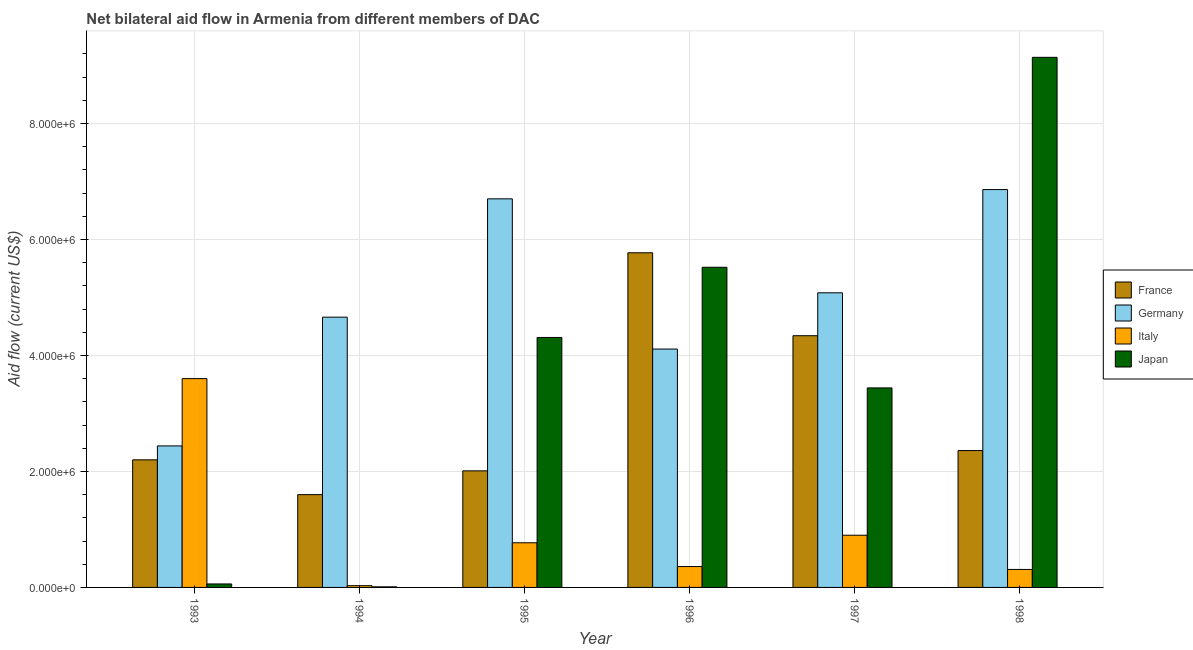How many bars are there on the 1st tick from the left?
Give a very brief answer. 4. What is the amount of aid given by italy in 1997?
Your answer should be compact. 9.00e+05. Across all years, what is the maximum amount of aid given by japan?
Your answer should be compact. 9.14e+06. Across all years, what is the minimum amount of aid given by italy?
Your response must be concise. 3.00e+04. In which year was the amount of aid given by japan maximum?
Provide a succinct answer. 1998. What is the total amount of aid given by france in the graph?
Make the answer very short. 1.83e+07. What is the difference between the amount of aid given by germany in 1994 and that in 1995?
Offer a very short reply. -2.04e+06. What is the difference between the amount of aid given by italy in 1995 and the amount of aid given by france in 1997?
Your answer should be very brief. -1.30e+05. What is the average amount of aid given by italy per year?
Offer a terse response. 9.95e+05. In how many years, is the amount of aid given by japan greater than 1600000 US$?
Make the answer very short. 4. What is the ratio of the amount of aid given by japan in 1993 to that in 1998?
Offer a terse response. 0.01. Is the amount of aid given by italy in 1993 less than that in 1996?
Ensure brevity in your answer.  No. What is the difference between the highest and the second highest amount of aid given by germany?
Make the answer very short. 1.60e+05. What is the difference between the highest and the lowest amount of aid given by germany?
Your response must be concise. 4.42e+06. In how many years, is the amount of aid given by france greater than the average amount of aid given by france taken over all years?
Keep it short and to the point. 2. Is the sum of the amount of aid given by germany in 1993 and 1996 greater than the maximum amount of aid given by france across all years?
Your answer should be very brief. No. Is it the case that in every year, the sum of the amount of aid given by germany and amount of aid given by italy is greater than the sum of amount of aid given by japan and amount of aid given by france?
Give a very brief answer. No. What does the 3rd bar from the left in 1997 represents?
Make the answer very short. Italy. Is it the case that in every year, the sum of the amount of aid given by france and amount of aid given by germany is greater than the amount of aid given by italy?
Give a very brief answer. Yes. How many bars are there?
Provide a succinct answer. 24. Are all the bars in the graph horizontal?
Offer a terse response. No. What is the difference between two consecutive major ticks on the Y-axis?
Provide a short and direct response. 2.00e+06. Does the graph contain any zero values?
Your answer should be very brief. No. Where does the legend appear in the graph?
Keep it short and to the point. Center right. How many legend labels are there?
Give a very brief answer. 4. What is the title of the graph?
Your answer should be compact. Net bilateral aid flow in Armenia from different members of DAC. What is the label or title of the X-axis?
Ensure brevity in your answer.  Year. What is the Aid flow (current US$) in France in 1993?
Your answer should be very brief. 2.20e+06. What is the Aid flow (current US$) in Germany in 1993?
Ensure brevity in your answer.  2.44e+06. What is the Aid flow (current US$) of Italy in 1993?
Keep it short and to the point. 3.60e+06. What is the Aid flow (current US$) in Japan in 1993?
Offer a terse response. 6.00e+04. What is the Aid flow (current US$) in France in 1994?
Ensure brevity in your answer.  1.60e+06. What is the Aid flow (current US$) in Germany in 1994?
Make the answer very short. 4.66e+06. What is the Aid flow (current US$) in Italy in 1994?
Provide a short and direct response. 3.00e+04. What is the Aid flow (current US$) in Japan in 1994?
Make the answer very short. 10000. What is the Aid flow (current US$) in France in 1995?
Your answer should be compact. 2.01e+06. What is the Aid flow (current US$) in Germany in 1995?
Your answer should be compact. 6.70e+06. What is the Aid flow (current US$) in Italy in 1995?
Provide a short and direct response. 7.70e+05. What is the Aid flow (current US$) in Japan in 1995?
Provide a succinct answer. 4.31e+06. What is the Aid flow (current US$) in France in 1996?
Your answer should be compact. 5.77e+06. What is the Aid flow (current US$) in Germany in 1996?
Keep it short and to the point. 4.11e+06. What is the Aid flow (current US$) in Italy in 1996?
Ensure brevity in your answer.  3.60e+05. What is the Aid flow (current US$) in Japan in 1996?
Make the answer very short. 5.52e+06. What is the Aid flow (current US$) of France in 1997?
Offer a terse response. 4.34e+06. What is the Aid flow (current US$) in Germany in 1997?
Provide a short and direct response. 5.08e+06. What is the Aid flow (current US$) of Japan in 1997?
Offer a terse response. 3.44e+06. What is the Aid flow (current US$) in France in 1998?
Keep it short and to the point. 2.36e+06. What is the Aid flow (current US$) in Germany in 1998?
Keep it short and to the point. 6.86e+06. What is the Aid flow (current US$) in Italy in 1998?
Keep it short and to the point. 3.10e+05. What is the Aid flow (current US$) in Japan in 1998?
Keep it short and to the point. 9.14e+06. Across all years, what is the maximum Aid flow (current US$) in France?
Offer a terse response. 5.77e+06. Across all years, what is the maximum Aid flow (current US$) in Germany?
Provide a short and direct response. 6.86e+06. Across all years, what is the maximum Aid flow (current US$) in Italy?
Provide a succinct answer. 3.60e+06. Across all years, what is the maximum Aid flow (current US$) in Japan?
Your answer should be compact. 9.14e+06. Across all years, what is the minimum Aid flow (current US$) in France?
Make the answer very short. 1.60e+06. Across all years, what is the minimum Aid flow (current US$) in Germany?
Offer a terse response. 2.44e+06. What is the total Aid flow (current US$) of France in the graph?
Your answer should be very brief. 1.83e+07. What is the total Aid flow (current US$) of Germany in the graph?
Your response must be concise. 2.98e+07. What is the total Aid flow (current US$) of Italy in the graph?
Offer a terse response. 5.97e+06. What is the total Aid flow (current US$) of Japan in the graph?
Provide a succinct answer. 2.25e+07. What is the difference between the Aid flow (current US$) in France in 1993 and that in 1994?
Keep it short and to the point. 6.00e+05. What is the difference between the Aid flow (current US$) in Germany in 1993 and that in 1994?
Your answer should be very brief. -2.22e+06. What is the difference between the Aid flow (current US$) in Italy in 1993 and that in 1994?
Make the answer very short. 3.57e+06. What is the difference between the Aid flow (current US$) in Japan in 1993 and that in 1994?
Provide a short and direct response. 5.00e+04. What is the difference between the Aid flow (current US$) of France in 1993 and that in 1995?
Your response must be concise. 1.90e+05. What is the difference between the Aid flow (current US$) of Germany in 1993 and that in 1995?
Give a very brief answer. -4.26e+06. What is the difference between the Aid flow (current US$) of Italy in 1993 and that in 1995?
Your answer should be very brief. 2.83e+06. What is the difference between the Aid flow (current US$) in Japan in 1993 and that in 1995?
Give a very brief answer. -4.25e+06. What is the difference between the Aid flow (current US$) in France in 1993 and that in 1996?
Make the answer very short. -3.57e+06. What is the difference between the Aid flow (current US$) of Germany in 1993 and that in 1996?
Give a very brief answer. -1.67e+06. What is the difference between the Aid flow (current US$) of Italy in 1993 and that in 1996?
Offer a terse response. 3.24e+06. What is the difference between the Aid flow (current US$) in Japan in 1993 and that in 1996?
Ensure brevity in your answer.  -5.46e+06. What is the difference between the Aid flow (current US$) in France in 1993 and that in 1997?
Your response must be concise. -2.14e+06. What is the difference between the Aid flow (current US$) of Germany in 1993 and that in 1997?
Provide a succinct answer. -2.64e+06. What is the difference between the Aid flow (current US$) in Italy in 1993 and that in 1997?
Offer a very short reply. 2.70e+06. What is the difference between the Aid flow (current US$) in Japan in 1993 and that in 1997?
Ensure brevity in your answer.  -3.38e+06. What is the difference between the Aid flow (current US$) in France in 1993 and that in 1998?
Offer a very short reply. -1.60e+05. What is the difference between the Aid flow (current US$) of Germany in 1993 and that in 1998?
Provide a succinct answer. -4.42e+06. What is the difference between the Aid flow (current US$) of Italy in 1993 and that in 1998?
Offer a very short reply. 3.29e+06. What is the difference between the Aid flow (current US$) in Japan in 1993 and that in 1998?
Offer a very short reply. -9.08e+06. What is the difference between the Aid flow (current US$) in France in 1994 and that in 1995?
Your answer should be compact. -4.10e+05. What is the difference between the Aid flow (current US$) of Germany in 1994 and that in 1995?
Your response must be concise. -2.04e+06. What is the difference between the Aid flow (current US$) in Italy in 1994 and that in 1995?
Offer a terse response. -7.40e+05. What is the difference between the Aid flow (current US$) in Japan in 1994 and that in 1995?
Provide a succinct answer. -4.30e+06. What is the difference between the Aid flow (current US$) in France in 1994 and that in 1996?
Your answer should be very brief. -4.17e+06. What is the difference between the Aid flow (current US$) in Germany in 1994 and that in 1996?
Your answer should be very brief. 5.50e+05. What is the difference between the Aid flow (current US$) of Italy in 1994 and that in 1996?
Provide a short and direct response. -3.30e+05. What is the difference between the Aid flow (current US$) in Japan in 1994 and that in 1996?
Provide a short and direct response. -5.51e+06. What is the difference between the Aid flow (current US$) in France in 1994 and that in 1997?
Give a very brief answer. -2.74e+06. What is the difference between the Aid flow (current US$) of Germany in 1994 and that in 1997?
Your answer should be very brief. -4.20e+05. What is the difference between the Aid flow (current US$) in Italy in 1994 and that in 1997?
Provide a short and direct response. -8.70e+05. What is the difference between the Aid flow (current US$) of Japan in 1994 and that in 1997?
Provide a short and direct response. -3.43e+06. What is the difference between the Aid flow (current US$) in France in 1994 and that in 1998?
Offer a terse response. -7.60e+05. What is the difference between the Aid flow (current US$) of Germany in 1994 and that in 1998?
Provide a succinct answer. -2.20e+06. What is the difference between the Aid flow (current US$) in Italy in 1994 and that in 1998?
Your response must be concise. -2.80e+05. What is the difference between the Aid flow (current US$) of Japan in 1994 and that in 1998?
Give a very brief answer. -9.13e+06. What is the difference between the Aid flow (current US$) of France in 1995 and that in 1996?
Give a very brief answer. -3.76e+06. What is the difference between the Aid flow (current US$) in Germany in 1995 and that in 1996?
Give a very brief answer. 2.59e+06. What is the difference between the Aid flow (current US$) of Japan in 1995 and that in 1996?
Ensure brevity in your answer.  -1.21e+06. What is the difference between the Aid flow (current US$) of France in 1995 and that in 1997?
Ensure brevity in your answer.  -2.33e+06. What is the difference between the Aid flow (current US$) of Germany in 1995 and that in 1997?
Offer a very short reply. 1.62e+06. What is the difference between the Aid flow (current US$) of Japan in 1995 and that in 1997?
Give a very brief answer. 8.70e+05. What is the difference between the Aid flow (current US$) of France in 1995 and that in 1998?
Your answer should be compact. -3.50e+05. What is the difference between the Aid flow (current US$) in Japan in 1995 and that in 1998?
Provide a short and direct response. -4.83e+06. What is the difference between the Aid flow (current US$) of France in 1996 and that in 1997?
Provide a succinct answer. 1.43e+06. What is the difference between the Aid flow (current US$) of Germany in 1996 and that in 1997?
Make the answer very short. -9.70e+05. What is the difference between the Aid flow (current US$) of Italy in 1996 and that in 1997?
Your answer should be compact. -5.40e+05. What is the difference between the Aid flow (current US$) of Japan in 1996 and that in 1997?
Ensure brevity in your answer.  2.08e+06. What is the difference between the Aid flow (current US$) in France in 1996 and that in 1998?
Keep it short and to the point. 3.41e+06. What is the difference between the Aid flow (current US$) in Germany in 1996 and that in 1998?
Give a very brief answer. -2.75e+06. What is the difference between the Aid flow (current US$) in Italy in 1996 and that in 1998?
Ensure brevity in your answer.  5.00e+04. What is the difference between the Aid flow (current US$) in Japan in 1996 and that in 1998?
Your response must be concise. -3.62e+06. What is the difference between the Aid flow (current US$) in France in 1997 and that in 1998?
Keep it short and to the point. 1.98e+06. What is the difference between the Aid flow (current US$) of Germany in 1997 and that in 1998?
Make the answer very short. -1.78e+06. What is the difference between the Aid flow (current US$) of Italy in 1997 and that in 1998?
Ensure brevity in your answer.  5.90e+05. What is the difference between the Aid flow (current US$) in Japan in 1997 and that in 1998?
Provide a succinct answer. -5.70e+06. What is the difference between the Aid flow (current US$) in France in 1993 and the Aid flow (current US$) in Germany in 1994?
Your response must be concise. -2.46e+06. What is the difference between the Aid flow (current US$) of France in 1993 and the Aid flow (current US$) of Italy in 1994?
Provide a short and direct response. 2.17e+06. What is the difference between the Aid flow (current US$) in France in 1993 and the Aid flow (current US$) in Japan in 1994?
Your answer should be very brief. 2.19e+06. What is the difference between the Aid flow (current US$) of Germany in 1993 and the Aid flow (current US$) of Italy in 1994?
Your answer should be very brief. 2.41e+06. What is the difference between the Aid flow (current US$) of Germany in 1993 and the Aid flow (current US$) of Japan in 1994?
Ensure brevity in your answer.  2.43e+06. What is the difference between the Aid flow (current US$) of Italy in 1993 and the Aid flow (current US$) of Japan in 1994?
Offer a very short reply. 3.59e+06. What is the difference between the Aid flow (current US$) in France in 1993 and the Aid flow (current US$) in Germany in 1995?
Provide a succinct answer. -4.50e+06. What is the difference between the Aid flow (current US$) of France in 1993 and the Aid flow (current US$) of Italy in 1995?
Keep it short and to the point. 1.43e+06. What is the difference between the Aid flow (current US$) in France in 1993 and the Aid flow (current US$) in Japan in 1995?
Provide a succinct answer. -2.11e+06. What is the difference between the Aid flow (current US$) in Germany in 1993 and the Aid flow (current US$) in Italy in 1995?
Provide a short and direct response. 1.67e+06. What is the difference between the Aid flow (current US$) in Germany in 1993 and the Aid flow (current US$) in Japan in 1995?
Your answer should be very brief. -1.87e+06. What is the difference between the Aid flow (current US$) of Italy in 1993 and the Aid flow (current US$) of Japan in 1995?
Your answer should be compact. -7.10e+05. What is the difference between the Aid flow (current US$) of France in 1993 and the Aid flow (current US$) of Germany in 1996?
Provide a succinct answer. -1.91e+06. What is the difference between the Aid flow (current US$) of France in 1993 and the Aid flow (current US$) of Italy in 1996?
Keep it short and to the point. 1.84e+06. What is the difference between the Aid flow (current US$) in France in 1993 and the Aid flow (current US$) in Japan in 1996?
Offer a very short reply. -3.32e+06. What is the difference between the Aid flow (current US$) in Germany in 1993 and the Aid flow (current US$) in Italy in 1996?
Provide a succinct answer. 2.08e+06. What is the difference between the Aid flow (current US$) of Germany in 1993 and the Aid flow (current US$) of Japan in 1996?
Offer a very short reply. -3.08e+06. What is the difference between the Aid flow (current US$) of Italy in 1993 and the Aid flow (current US$) of Japan in 1996?
Ensure brevity in your answer.  -1.92e+06. What is the difference between the Aid flow (current US$) of France in 1993 and the Aid flow (current US$) of Germany in 1997?
Offer a very short reply. -2.88e+06. What is the difference between the Aid flow (current US$) of France in 1993 and the Aid flow (current US$) of Italy in 1997?
Your response must be concise. 1.30e+06. What is the difference between the Aid flow (current US$) in France in 1993 and the Aid flow (current US$) in Japan in 1997?
Your response must be concise. -1.24e+06. What is the difference between the Aid flow (current US$) of Germany in 1993 and the Aid flow (current US$) of Italy in 1997?
Your answer should be compact. 1.54e+06. What is the difference between the Aid flow (current US$) in Germany in 1993 and the Aid flow (current US$) in Japan in 1997?
Your response must be concise. -1.00e+06. What is the difference between the Aid flow (current US$) of France in 1993 and the Aid flow (current US$) of Germany in 1998?
Make the answer very short. -4.66e+06. What is the difference between the Aid flow (current US$) in France in 1993 and the Aid flow (current US$) in Italy in 1998?
Your answer should be very brief. 1.89e+06. What is the difference between the Aid flow (current US$) in France in 1993 and the Aid flow (current US$) in Japan in 1998?
Ensure brevity in your answer.  -6.94e+06. What is the difference between the Aid flow (current US$) in Germany in 1993 and the Aid flow (current US$) in Italy in 1998?
Offer a very short reply. 2.13e+06. What is the difference between the Aid flow (current US$) of Germany in 1993 and the Aid flow (current US$) of Japan in 1998?
Provide a short and direct response. -6.70e+06. What is the difference between the Aid flow (current US$) in Italy in 1993 and the Aid flow (current US$) in Japan in 1998?
Your answer should be very brief. -5.54e+06. What is the difference between the Aid flow (current US$) in France in 1994 and the Aid flow (current US$) in Germany in 1995?
Your answer should be very brief. -5.10e+06. What is the difference between the Aid flow (current US$) of France in 1994 and the Aid flow (current US$) of Italy in 1995?
Provide a short and direct response. 8.30e+05. What is the difference between the Aid flow (current US$) of France in 1994 and the Aid flow (current US$) of Japan in 1995?
Make the answer very short. -2.71e+06. What is the difference between the Aid flow (current US$) of Germany in 1994 and the Aid flow (current US$) of Italy in 1995?
Offer a very short reply. 3.89e+06. What is the difference between the Aid flow (current US$) in Italy in 1994 and the Aid flow (current US$) in Japan in 1995?
Make the answer very short. -4.28e+06. What is the difference between the Aid flow (current US$) of France in 1994 and the Aid flow (current US$) of Germany in 1996?
Provide a succinct answer. -2.51e+06. What is the difference between the Aid flow (current US$) of France in 1994 and the Aid flow (current US$) of Italy in 1996?
Offer a terse response. 1.24e+06. What is the difference between the Aid flow (current US$) in France in 1994 and the Aid flow (current US$) in Japan in 1996?
Keep it short and to the point. -3.92e+06. What is the difference between the Aid flow (current US$) in Germany in 1994 and the Aid flow (current US$) in Italy in 1996?
Offer a terse response. 4.30e+06. What is the difference between the Aid flow (current US$) of Germany in 1994 and the Aid flow (current US$) of Japan in 1996?
Offer a terse response. -8.60e+05. What is the difference between the Aid flow (current US$) in Italy in 1994 and the Aid flow (current US$) in Japan in 1996?
Your answer should be compact. -5.49e+06. What is the difference between the Aid flow (current US$) of France in 1994 and the Aid flow (current US$) of Germany in 1997?
Your response must be concise. -3.48e+06. What is the difference between the Aid flow (current US$) of France in 1994 and the Aid flow (current US$) of Japan in 1997?
Offer a terse response. -1.84e+06. What is the difference between the Aid flow (current US$) in Germany in 1994 and the Aid flow (current US$) in Italy in 1997?
Keep it short and to the point. 3.76e+06. What is the difference between the Aid flow (current US$) in Germany in 1994 and the Aid flow (current US$) in Japan in 1997?
Make the answer very short. 1.22e+06. What is the difference between the Aid flow (current US$) in Italy in 1994 and the Aid flow (current US$) in Japan in 1997?
Offer a very short reply. -3.41e+06. What is the difference between the Aid flow (current US$) in France in 1994 and the Aid flow (current US$) in Germany in 1998?
Your answer should be compact. -5.26e+06. What is the difference between the Aid flow (current US$) of France in 1994 and the Aid flow (current US$) of Italy in 1998?
Keep it short and to the point. 1.29e+06. What is the difference between the Aid flow (current US$) of France in 1994 and the Aid flow (current US$) of Japan in 1998?
Make the answer very short. -7.54e+06. What is the difference between the Aid flow (current US$) in Germany in 1994 and the Aid flow (current US$) in Italy in 1998?
Make the answer very short. 4.35e+06. What is the difference between the Aid flow (current US$) of Germany in 1994 and the Aid flow (current US$) of Japan in 1998?
Provide a succinct answer. -4.48e+06. What is the difference between the Aid flow (current US$) in Italy in 1994 and the Aid flow (current US$) in Japan in 1998?
Your response must be concise. -9.11e+06. What is the difference between the Aid flow (current US$) in France in 1995 and the Aid flow (current US$) in Germany in 1996?
Your response must be concise. -2.10e+06. What is the difference between the Aid flow (current US$) of France in 1995 and the Aid flow (current US$) of Italy in 1996?
Make the answer very short. 1.65e+06. What is the difference between the Aid flow (current US$) in France in 1995 and the Aid flow (current US$) in Japan in 1996?
Make the answer very short. -3.51e+06. What is the difference between the Aid flow (current US$) in Germany in 1995 and the Aid flow (current US$) in Italy in 1996?
Your answer should be very brief. 6.34e+06. What is the difference between the Aid flow (current US$) in Germany in 1995 and the Aid flow (current US$) in Japan in 1996?
Offer a very short reply. 1.18e+06. What is the difference between the Aid flow (current US$) in Italy in 1995 and the Aid flow (current US$) in Japan in 1996?
Make the answer very short. -4.75e+06. What is the difference between the Aid flow (current US$) of France in 1995 and the Aid flow (current US$) of Germany in 1997?
Ensure brevity in your answer.  -3.07e+06. What is the difference between the Aid flow (current US$) in France in 1995 and the Aid flow (current US$) in Italy in 1997?
Provide a short and direct response. 1.11e+06. What is the difference between the Aid flow (current US$) in France in 1995 and the Aid flow (current US$) in Japan in 1997?
Offer a terse response. -1.43e+06. What is the difference between the Aid flow (current US$) of Germany in 1995 and the Aid flow (current US$) of Italy in 1997?
Provide a succinct answer. 5.80e+06. What is the difference between the Aid flow (current US$) in Germany in 1995 and the Aid flow (current US$) in Japan in 1997?
Ensure brevity in your answer.  3.26e+06. What is the difference between the Aid flow (current US$) in Italy in 1995 and the Aid flow (current US$) in Japan in 1997?
Provide a succinct answer. -2.67e+06. What is the difference between the Aid flow (current US$) in France in 1995 and the Aid flow (current US$) in Germany in 1998?
Offer a terse response. -4.85e+06. What is the difference between the Aid flow (current US$) in France in 1995 and the Aid flow (current US$) in Italy in 1998?
Your answer should be compact. 1.70e+06. What is the difference between the Aid flow (current US$) in France in 1995 and the Aid flow (current US$) in Japan in 1998?
Make the answer very short. -7.13e+06. What is the difference between the Aid flow (current US$) of Germany in 1995 and the Aid flow (current US$) of Italy in 1998?
Offer a terse response. 6.39e+06. What is the difference between the Aid flow (current US$) of Germany in 1995 and the Aid flow (current US$) of Japan in 1998?
Ensure brevity in your answer.  -2.44e+06. What is the difference between the Aid flow (current US$) in Italy in 1995 and the Aid flow (current US$) in Japan in 1998?
Offer a terse response. -8.37e+06. What is the difference between the Aid flow (current US$) of France in 1996 and the Aid flow (current US$) of Germany in 1997?
Provide a succinct answer. 6.90e+05. What is the difference between the Aid flow (current US$) in France in 1996 and the Aid flow (current US$) in Italy in 1997?
Offer a terse response. 4.87e+06. What is the difference between the Aid flow (current US$) of France in 1996 and the Aid flow (current US$) of Japan in 1997?
Offer a very short reply. 2.33e+06. What is the difference between the Aid flow (current US$) in Germany in 1996 and the Aid flow (current US$) in Italy in 1997?
Provide a short and direct response. 3.21e+06. What is the difference between the Aid flow (current US$) in Germany in 1996 and the Aid flow (current US$) in Japan in 1997?
Your response must be concise. 6.70e+05. What is the difference between the Aid flow (current US$) in Italy in 1996 and the Aid flow (current US$) in Japan in 1997?
Keep it short and to the point. -3.08e+06. What is the difference between the Aid flow (current US$) of France in 1996 and the Aid flow (current US$) of Germany in 1998?
Ensure brevity in your answer.  -1.09e+06. What is the difference between the Aid flow (current US$) in France in 1996 and the Aid flow (current US$) in Italy in 1998?
Your answer should be very brief. 5.46e+06. What is the difference between the Aid flow (current US$) of France in 1996 and the Aid flow (current US$) of Japan in 1998?
Make the answer very short. -3.37e+06. What is the difference between the Aid flow (current US$) in Germany in 1996 and the Aid flow (current US$) in Italy in 1998?
Keep it short and to the point. 3.80e+06. What is the difference between the Aid flow (current US$) in Germany in 1996 and the Aid flow (current US$) in Japan in 1998?
Offer a very short reply. -5.03e+06. What is the difference between the Aid flow (current US$) in Italy in 1996 and the Aid flow (current US$) in Japan in 1998?
Your answer should be compact. -8.78e+06. What is the difference between the Aid flow (current US$) of France in 1997 and the Aid flow (current US$) of Germany in 1998?
Your response must be concise. -2.52e+06. What is the difference between the Aid flow (current US$) in France in 1997 and the Aid flow (current US$) in Italy in 1998?
Make the answer very short. 4.03e+06. What is the difference between the Aid flow (current US$) of France in 1997 and the Aid flow (current US$) of Japan in 1998?
Provide a short and direct response. -4.80e+06. What is the difference between the Aid flow (current US$) in Germany in 1997 and the Aid flow (current US$) in Italy in 1998?
Make the answer very short. 4.77e+06. What is the difference between the Aid flow (current US$) of Germany in 1997 and the Aid flow (current US$) of Japan in 1998?
Provide a succinct answer. -4.06e+06. What is the difference between the Aid flow (current US$) of Italy in 1997 and the Aid flow (current US$) of Japan in 1998?
Your answer should be compact. -8.24e+06. What is the average Aid flow (current US$) of France per year?
Ensure brevity in your answer.  3.05e+06. What is the average Aid flow (current US$) of Germany per year?
Your answer should be compact. 4.98e+06. What is the average Aid flow (current US$) of Italy per year?
Your response must be concise. 9.95e+05. What is the average Aid flow (current US$) of Japan per year?
Provide a short and direct response. 3.75e+06. In the year 1993, what is the difference between the Aid flow (current US$) in France and Aid flow (current US$) in Italy?
Offer a very short reply. -1.40e+06. In the year 1993, what is the difference between the Aid flow (current US$) of France and Aid flow (current US$) of Japan?
Offer a terse response. 2.14e+06. In the year 1993, what is the difference between the Aid flow (current US$) of Germany and Aid flow (current US$) of Italy?
Provide a short and direct response. -1.16e+06. In the year 1993, what is the difference between the Aid flow (current US$) of Germany and Aid flow (current US$) of Japan?
Your answer should be very brief. 2.38e+06. In the year 1993, what is the difference between the Aid flow (current US$) of Italy and Aid flow (current US$) of Japan?
Your answer should be very brief. 3.54e+06. In the year 1994, what is the difference between the Aid flow (current US$) in France and Aid flow (current US$) in Germany?
Your answer should be very brief. -3.06e+06. In the year 1994, what is the difference between the Aid flow (current US$) in France and Aid flow (current US$) in Italy?
Your answer should be compact. 1.57e+06. In the year 1994, what is the difference between the Aid flow (current US$) of France and Aid flow (current US$) of Japan?
Ensure brevity in your answer.  1.59e+06. In the year 1994, what is the difference between the Aid flow (current US$) of Germany and Aid flow (current US$) of Italy?
Your answer should be very brief. 4.63e+06. In the year 1994, what is the difference between the Aid flow (current US$) in Germany and Aid flow (current US$) in Japan?
Your response must be concise. 4.65e+06. In the year 1994, what is the difference between the Aid flow (current US$) of Italy and Aid flow (current US$) of Japan?
Give a very brief answer. 2.00e+04. In the year 1995, what is the difference between the Aid flow (current US$) in France and Aid flow (current US$) in Germany?
Offer a very short reply. -4.69e+06. In the year 1995, what is the difference between the Aid flow (current US$) in France and Aid flow (current US$) in Italy?
Your response must be concise. 1.24e+06. In the year 1995, what is the difference between the Aid flow (current US$) in France and Aid flow (current US$) in Japan?
Offer a very short reply. -2.30e+06. In the year 1995, what is the difference between the Aid flow (current US$) in Germany and Aid flow (current US$) in Italy?
Provide a short and direct response. 5.93e+06. In the year 1995, what is the difference between the Aid flow (current US$) in Germany and Aid flow (current US$) in Japan?
Your answer should be compact. 2.39e+06. In the year 1995, what is the difference between the Aid flow (current US$) in Italy and Aid flow (current US$) in Japan?
Provide a short and direct response. -3.54e+06. In the year 1996, what is the difference between the Aid flow (current US$) in France and Aid flow (current US$) in Germany?
Offer a very short reply. 1.66e+06. In the year 1996, what is the difference between the Aid flow (current US$) in France and Aid flow (current US$) in Italy?
Offer a very short reply. 5.41e+06. In the year 1996, what is the difference between the Aid flow (current US$) of France and Aid flow (current US$) of Japan?
Make the answer very short. 2.50e+05. In the year 1996, what is the difference between the Aid flow (current US$) in Germany and Aid flow (current US$) in Italy?
Provide a succinct answer. 3.75e+06. In the year 1996, what is the difference between the Aid flow (current US$) in Germany and Aid flow (current US$) in Japan?
Offer a very short reply. -1.41e+06. In the year 1996, what is the difference between the Aid flow (current US$) in Italy and Aid flow (current US$) in Japan?
Offer a very short reply. -5.16e+06. In the year 1997, what is the difference between the Aid flow (current US$) in France and Aid flow (current US$) in Germany?
Keep it short and to the point. -7.40e+05. In the year 1997, what is the difference between the Aid flow (current US$) of France and Aid flow (current US$) of Italy?
Give a very brief answer. 3.44e+06. In the year 1997, what is the difference between the Aid flow (current US$) of France and Aid flow (current US$) of Japan?
Keep it short and to the point. 9.00e+05. In the year 1997, what is the difference between the Aid flow (current US$) of Germany and Aid flow (current US$) of Italy?
Your answer should be very brief. 4.18e+06. In the year 1997, what is the difference between the Aid flow (current US$) in Germany and Aid flow (current US$) in Japan?
Provide a succinct answer. 1.64e+06. In the year 1997, what is the difference between the Aid flow (current US$) in Italy and Aid flow (current US$) in Japan?
Offer a terse response. -2.54e+06. In the year 1998, what is the difference between the Aid flow (current US$) of France and Aid flow (current US$) of Germany?
Offer a very short reply. -4.50e+06. In the year 1998, what is the difference between the Aid flow (current US$) of France and Aid flow (current US$) of Italy?
Give a very brief answer. 2.05e+06. In the year 1998, what is the difference between the Aid flow (current US$) in France and Aid flow (current US$) in Japan?
Give a very brief answer. -6.78e+06. In the year 1998, what is the difference between the Aid flow (current US$) of Germany and Aid flow (current US$) of Italy?
Your response must be concise. 6.55e+06. In the year 1998, what is the difference between the Aid flow (current US$) of Germany and Aid flow (current US$) of Japan?
Ensure brevity in your answer.  -2.28e+06. In the year 1998, what is the difference between the Aid flow (current US$) of Italy and Aid flow (current US$) of Japan?
Your answer should be compact. -8.83e+06. What is the ratio of the Aid flow (current US$) in France in 1993 to that in 1994?
Your answer should be compact. 1.38. What is the ratio of the Aid flow (current US$) in Germany in 1993 to that in 1994?
Ensure brevity in your answer.  0.52. What is the ratio of the Aid flow (current US$) in Italy in 1993 to that in 1994?
Offer a very short reply. 120. What is the ratio of the Aid flow (current US$) of France in 1993 to that in 1995?
Give a very brief answer. 1.09. What is the ratio of the Aid flow (current US$) of Germany in 1993 to that in 1995?
Provide a succinct answer. 0.36. What is the ratio of the Aid flow (current US$) in Italy in 1993 to that in 1995?
Make the answer very short. 4.68. What is the ratio of the Aid flow (current US$) of Japan in 1993 to that in 1995?
Your answer should be compact. 0.01. What is the ratio of the Aid flow (current US$) in France in 1993 to that in 1996?
Provide a short and direct response. 0.38. What is the ratio of the Aid flow (current US$) of Germany in 1993 to that in 1996?
Provide a succinct answer. 0.59. What is the ratio of the Aid flow (current US$) in Italy in 1993 to that in 1996?
Provide a succinct answer. 10. What is the ratio of the Aid flow (current US$) of Japan in 1993 to that in 1996?
Offer a very short reply. 0.01. What is the ratio of the Aid flow (current US$) of France in 1993 to that in 1997?
Your answer should be compact. 0.51. What is the ratio of the Aid flow (current US$) in Germany in 1993 to that in 1997?
Provide a succinct answer. 0.48. What is the ratio of the Aid flow (current US$) of Italy in 1993 to that in 1997?
Your answer should be very brief. 4. What is the ratio of the Aid flow (current US$) in Japan in 1993 to that in 1997?
Your answer should be compact. 0.02. What is the ratio of the Aid flow (current US$) of France in 1993 to that in 1998?
Ensure brevity in your answer.  0.93. What is the ratio of the Aid flow (current US$) in Germany in 1993 to that in 1998?
Make the answer very short. 0.36. What is the ratio of the Aid flow (current US$) of Italy in 1993 to that in 1998?
Your response must be concise. 11.61. What is the ratio of the Aid flow (current US$) of Japan in 1993 to that in 1998?
Give a very brief answer. 0.01. What is the ratio of the Aid flow (current US$) of France in 1994 to that in 1995?
Your response must be concise. 0.8. What is the ratio of the Aid flow (current US$) in Germany in 1994 to that in 1995?
Your response must be concise. 0.7. What is the ratio of the Aid flow (current US$) in Italy in 1994 to that in 1995?
Your response must be concise. 0.04. What is the ratio of the Aid flow (current US$) of Japan in 1994 to that in 1995?
Your answer should be compact. 0. What is the ratio of the Aid flow (current US$) in France in 1994 to that in 1996?
Make the answer very short. 0.28. What is the ratio of the Aid flow (current US$) in Germany in 1994 to that in 1996?
Your response must be concise. 1.13. What is the ratio of the Aid flow (current US$) of Italy in 1994 to that in 1996?
Keep it short and to the point. 0.08. What is the ratio of the Aid flow (current US$) in Japan in 1994 to that in 1996?
Keep it short and to the point. 0. What is the ratio of the Aid flow (current US$) in France in 1994 to that in 1997?
Keep it short and to the point. 0.37. What is the ratio of the Aid flow (current US$) in Germany in 1994 to that in 1997?
Your answer should be compact. 0.92. What is the ratio of the Aid flow (current US$) in Italy in 1994 to that in 1997?
Offer a very short reply. 0.03. What is the ratio of the Aid flow (current US$) of Japan in 1994 to that in 1997?
Provide a short and direct response. 0. What is the ratio of the Aid flow (current US$) in France in 1994 to that in 1998?
Ensure brevity in your answer.  0.68. What is the ratio of the Aid flow (current US$) in Germany in 1994 to that in 1998?
Your answer should be very brief. 0.68. What is the ratio of the Aid flow (current US$) of Italy in 1994 to that in 1998?
Provide a succinct answer. 0.1. What is the ratio of the Aid flow (current US$) in Japan in 1994 to that in 1998?
Ensure brevity in your answer.  0. What is the ratio of the Aid flow (current US$) in France in 1995 to that in 1996?
Keep it short and to the point. 0.35. What is the ratio of the Aid flow (current US$) in Germany in 1995 to that in 1996?
Your answer should be compact. 1.63. What is the ratio of the Aid flow (current US$) of Italy in 1995 to that in 1996?
Your answer should be very brief. 2.14. What is the ratio of the Aid flow (current US$) in Japan in 1995 to that in 1996?
Your answer should be very brief. 0.78. What is the ratio of the Aid flow (current US$) in France in 1995 to that in 1997?
Your answer should be very brief. 0.46. What is the ratio of the Aid flow (current US$) in Germany in 1995 to that in 1997?
Ensure brevity in your answer.  1.32. What is the ratio of the Aid flow (current US$) of Italy in 1995 to that in 1997?
Give a very brief answer. 0.86. What is the ratio of the Aid flow (current US$) in Japan in 1995 to that in 1997?
Your answer should be very brief. 1.25. What is the ratio of the Aid flow (current US$) of France in 1995 to that in 1998?
Keep it short and to the point. 0.85. What is the ratio of the Aid flow (current US$) in Germany in 1995 to that in 1998?
Keep it short and to the point. 0.98. What is the ratio of the Aid flow (current US$) of Italy in 1995 to that in 1998?
Make the answer very short. 2.48. What is the ratio of the Aid flow (current US$) in Japan in 1995 to that in 1998?
Your response must be concise. 0.47. What is the ratio of the Aid flow (current US$) of France in 1996 to that in 1997?
Offer a terse response. 1.33. What is the ratio of the Aid flow (current US$) of Germany in 1996 to that in 1997?
Give a very brief answer. 0.81. What is the ratio of the Aid flow (current US$) in Japan in 1996 to that in 1997?
Keep it short and to the point. 1.6. What is the ratio of the Aid flow (current US$) in France in 1996 to that in 1998?
Offer a very short reply. 2.44. What is the ratio of the Aid flow (current US$) of Germany in 1996 to that in 1998?
Your response must be concise. 0.6. What is the ratio of the Aid flow (current US$) of Italy in 1996 to that in 1998?
Offer a terse response. 1.16. What is the ratio of the Aid flow (current US$) in Japan in 1996 to that in 1998?
Give a very brief answer. 0.6. What is the ratio of the Aid flow (current US$) in France in 1997 to that in 1998?
Offer a terse response. 1.84. What is the ratio of the Aid flow (current US$) of Germany in 1997 to that in 1998?
Provide a succinct answer. 0.74. What is the ratio of the Aid flow (current US$) in Italy in 1997 to that in 1998?
Ensure brevity in your answer.  2.9. What is the ratio of the Aid flow (current US$) in Japan in 1997 to that in 1998?
Provide a short and direct response. 0.38. What is the difference between the highest and the second highest Aid flow (current US$) in France?
Make the answer very short. 1.43e+06. What is the difference between the highest and the second highest Aid flow (current US$) in Italy?
Provide a succinct answer. 2.70e+06. What is the difference between the highest and the second highest Aid flow (current US$) of Japan?
Offer a terse response. 3.62e+06. What is the difference between the highest and the lowest Aid flow (current US$) in France?
Offer a terse response. 4.17e+06. What is the difference between the highest and the lowest Aid flow (current US$) of Germany?
Keep it short and to the point. 4.42e+06. What is the difference between the highest and the lowest Aid flow (current US$) of Italy?
Make the answer very short. 3.57e+06. What is the difference between the highest and the lowest Aid flow (current US$) of Japan?
Offer a very short reply. 9.13e+06. 